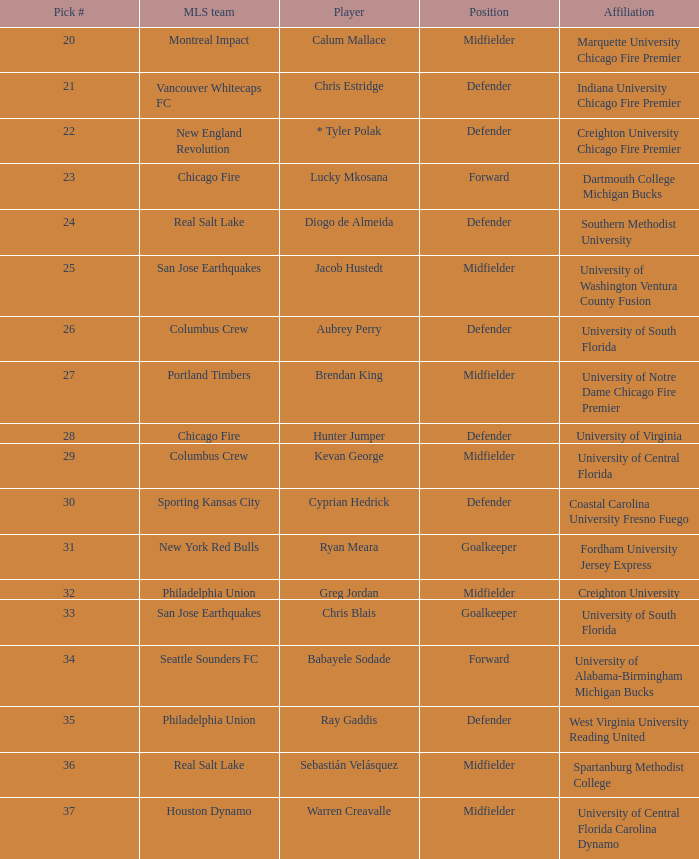What major league soccer team drafted babayele sodade? Seattle Sounders FC. 